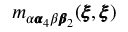<formula> <loc_0><loc_0><loc_500><loc_500>m _ { \alpha { \pm b \alpha } _ { 4 } \beta { \pm b \beta } _ { 2 } } ( { \pm b \xi } , { \pm b \xi } )</formula> 